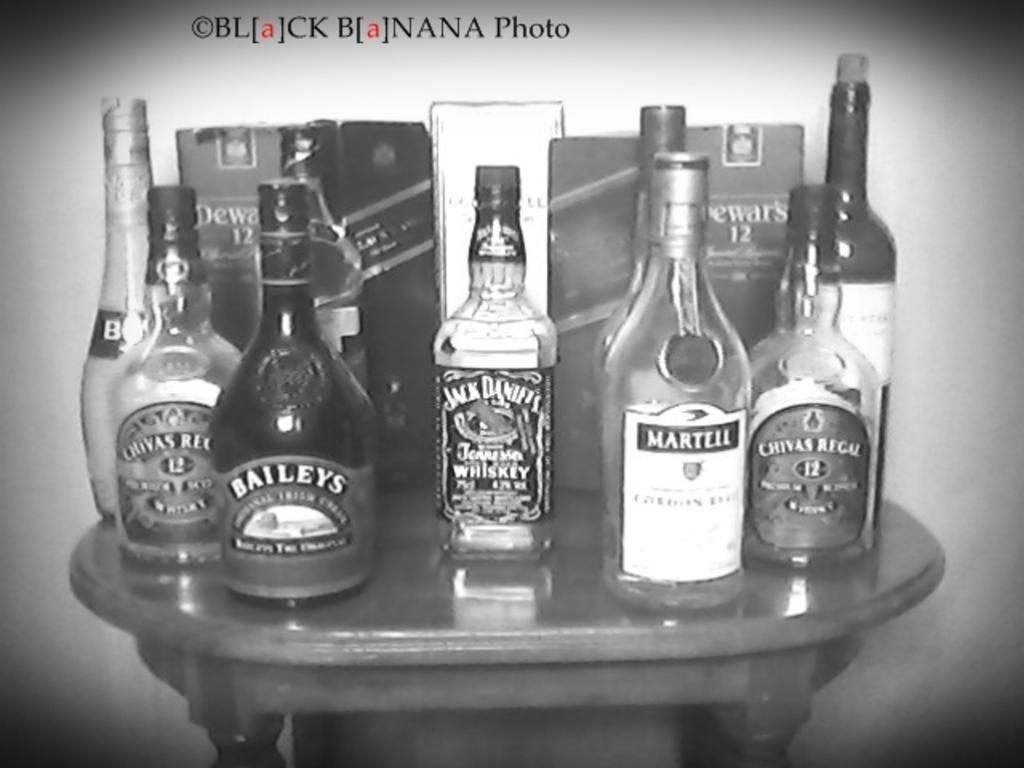What brand of whiskey to the far left?
Your answer should be very brief. Chivas. 